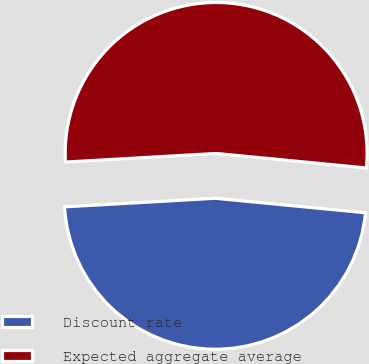Convert chart. <chart><loc_0><loc_0><loc_500><loc_500><pie_chart><fcel>Discount rate<fcel>Expected aggregate average<nl><fcel>47.56%<fcel>52.44%<nl></chart> 